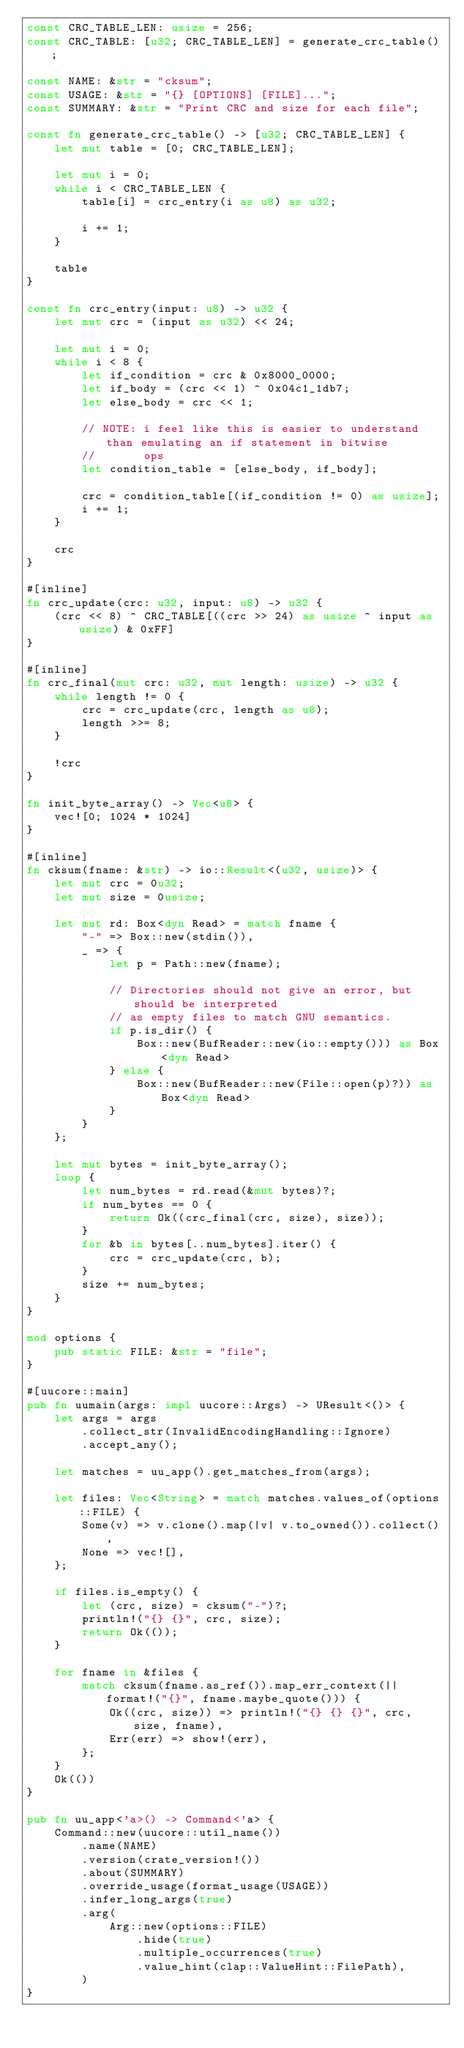Convert code to text. <code><loc_0><loc_0><loc_500><loc_500><_Rust_>const CRC_TABLE_LEN: usize = 256;
const CRC_TABLE: [u32; CRC_TABLE_LEN] = generate_crc_table();

const NAME: &str = "cksum";
const USAGE: &str = "{} [OPTIONS] [FILE]...";
const SUMMARY: &str = "Print CRC and size for each file";

const fn generate_crc_table() -> [u32; CRC_TABLE_LEN] {
    let mut table = [0; CRC_TABLE_LEN];

    let mut i = 0;
    while i < CRC_TABLE_LEN {
        table[i] = crc_entry(i as u8) as u32;

        i += 1;
    }

    table
}

const fn crc_entry(input: u8) -> u32 {
    let mut crc = (input as u32) << 24;

    let mut i = 0;
    while i < 8 {
        let if_condition = crc & 0x8000_0000;
        let if_body = (crc << 1) ^ 0x04c1_1db7;
        let else_body = crc << 1;

        // NOTE: i feel like this is easier to understand than emulating an if statement in bitwise
        //       ops
        let condition_table = [else_body, if_body];

        crc = condition_table[(if_condition != 0) as usize];
        i += 1;
    }

    crc
}

#[inline]
fn crc_update(crc: u32, input: u8) -> u32 {
    (crc << 8) ^ CRC_TABLE[((crc >> 24) as usize ^ input as usize) & 0xFF]
}

#[inline]
fn crc_final(mut crc: u32, mut length: usize) -> u32 {
    while length != 0 {
        crc = crc_update(crc, length as u8);
        length >>= 8;
    }

    !crc
}

fn init_byte_array() -> Vec<u8> {
    vec![0; 1024 * 1024]
}

#[inline]
fn cksum(fname: &str) -> io::Result<(u32, usize)> {
    let mut crc = 0u32;
    let mut size = 0usize;

    let mut rd: Box<dyn Read> = match fname {
        "-" => Box::new(stdin()),
        _ => {
            let p = Path::new(fname);

            // Directories should not give an error, but should be interpreted
            // as empty files to match GNU semantics.
            if p.is_dir() {
                Box::new(BufReader::new(io::empty())) as Box<dyn Read>
            } else {
                Box::new(BufReader::new(File::open(p)?)) as Box<dyn Read>
            }
        }
    };

    let mut bytes = init_byte_array();
    loop {
        let num_bytes = rd.read(&mut bytes)?;
        if num_bytes == 0 {
            return Ok((crc_final(crc, size), size));
        }
        for &b in bytes[..num_bytes].iter() {
            crc = crc_update(crc, b);
        }
        size += num_bytes;
    }
}

mod options {
    pub static FILE: &str = "file";
}

#[uucore::main]
pub fn uumain(args: impl uucore::Args) -> UResult<()> {
    let args = args
        .collect_str(InvalidEncodingHandling::Ignore)
        .accept_any();

    let matches = uu_app().get_matches_from(args);

    let files: Vec<String> = match matches.values_of(options::FILE) {
        Some(v) => v.clone().map(|v| v.to_owned()).collect(),
        None => vec![],
    };

    if files.is_empty() {
        let (crc, size) = cksum("-")?;
        println!("{} {}", crc, size);
        return Ok(());
    }

    for fname in &files {
        match cksum(fname.as_ref()).map_err_context(|| format!("{}", fname.maybe_quote())) {
            Ok((crc, size)) => println!("{} {} {}", crc, size, fname),
            Err(err) => show!(err),
        };
    }
    Ok(())
}

pub fn uu_app<'a>() -> Command<'a> {
    Command::new(uucore::util_name())
        .name(NAME)
        .version(crate_version!())
        .about(SUMMARY)
        .override_usage(format_usage(USAGE))
        .infer_long_args(true)
        .arg(
            Arg::new(options::FILE)
                .hide(true)
                .multiple_occurrences(true)
                .value_hint(clap::ValueHint::FilePath),
        )
}
</code> 